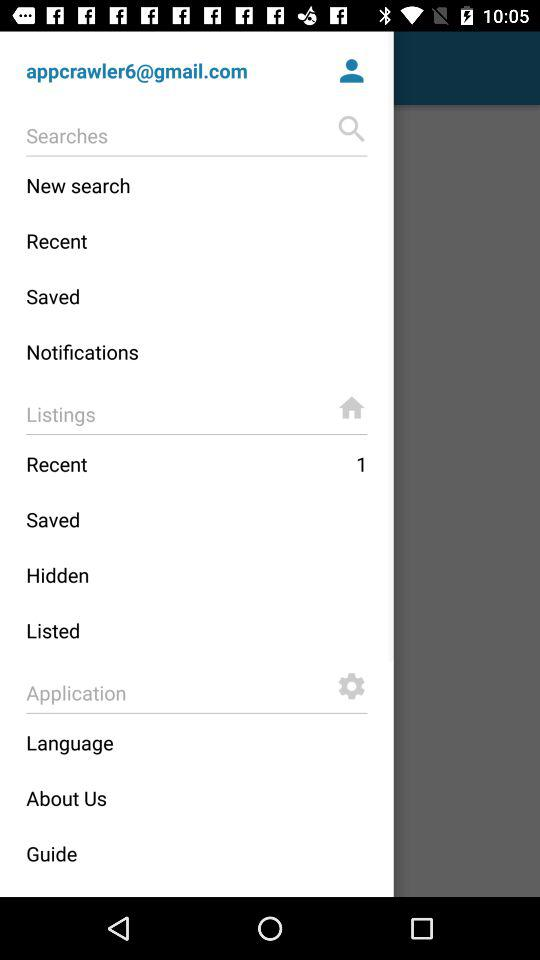What is the given email address? The given email address is appcrawler6@gmail.com. 